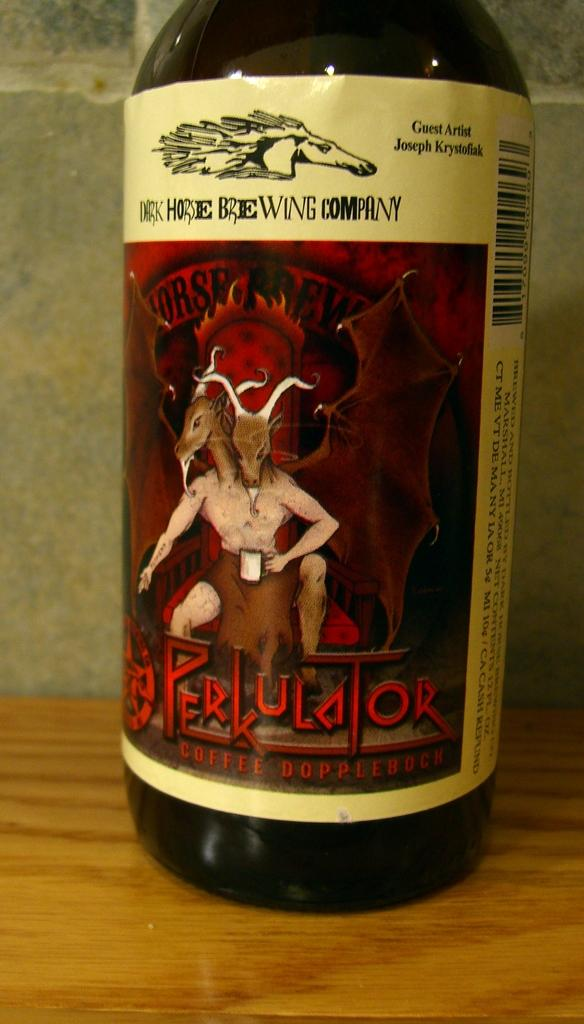Provide a one-sentence caption for the provided image. A bottle of Perkulator with a scary two headed demon on the label. 